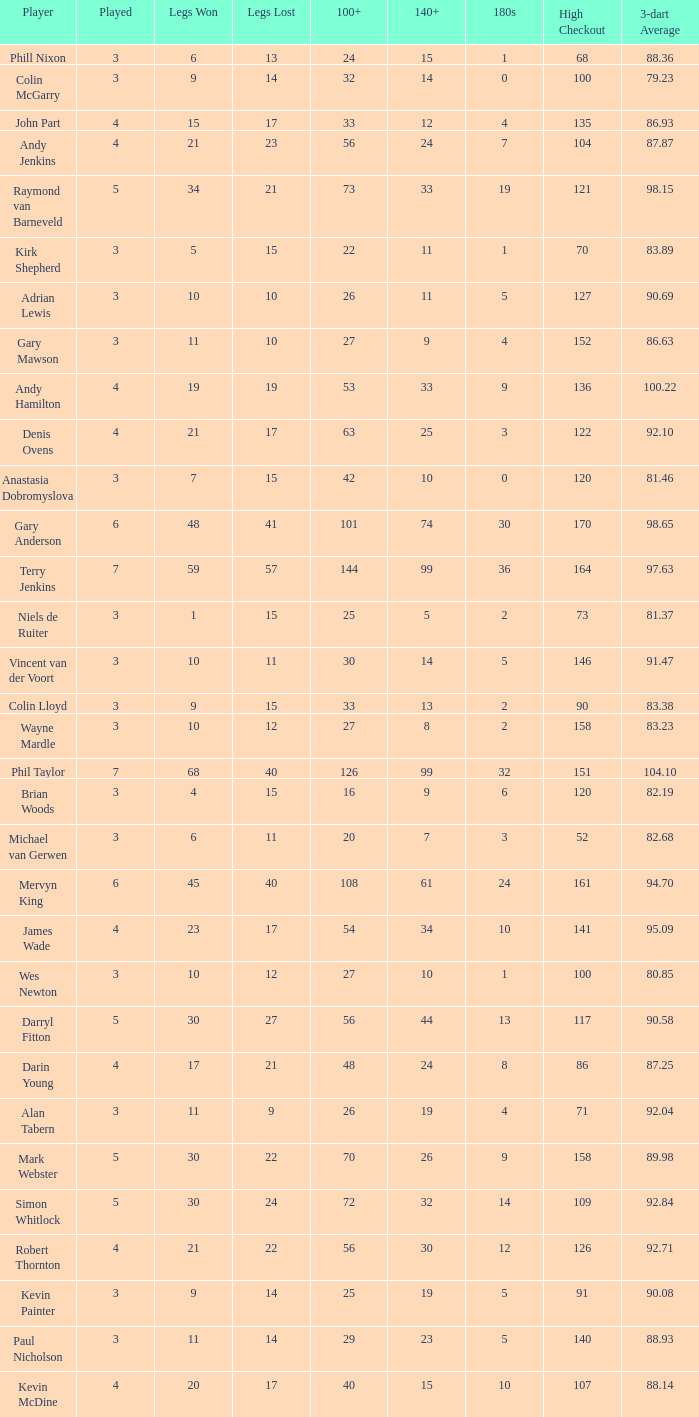What is the played number when the high checkout is 135? 4.0. 